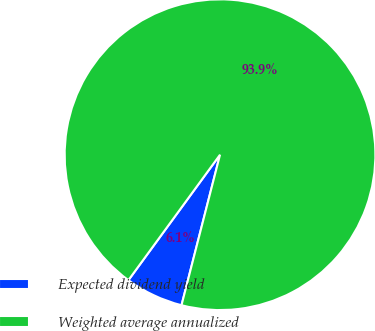Convert chart to OTSL. <chart><loc_0><loc_0><loc_500><loc_500><pie_chart><fcel>Expected dividend yield<fcel>Weighted average annualized<nl><fcel>6.05%<fcel>93.95%<nl></chart> 